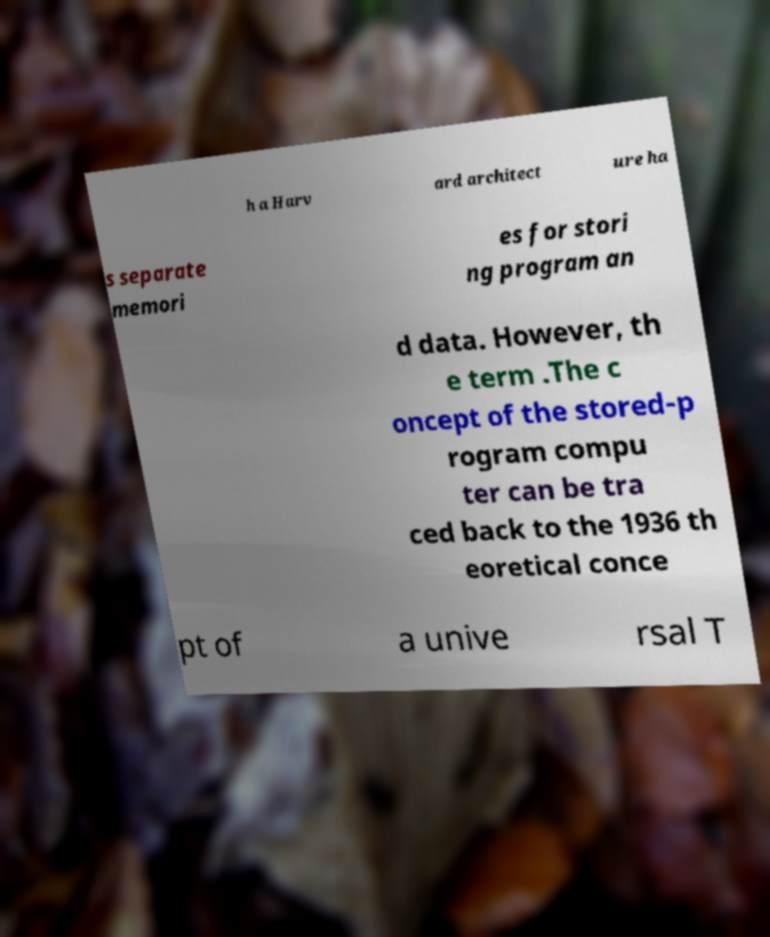Can you read and provide the text displayed in the image?This photo seems to have some interesting text. Can you extract and type it out for me? h a Harv ard architect ure ha s separate memori es for stori ng program an d data. However, th e term .The c oncept of the stored-p rogram compu ter can be tra ced back to the 1936 th eoretical conce pt of a unive rsal T 